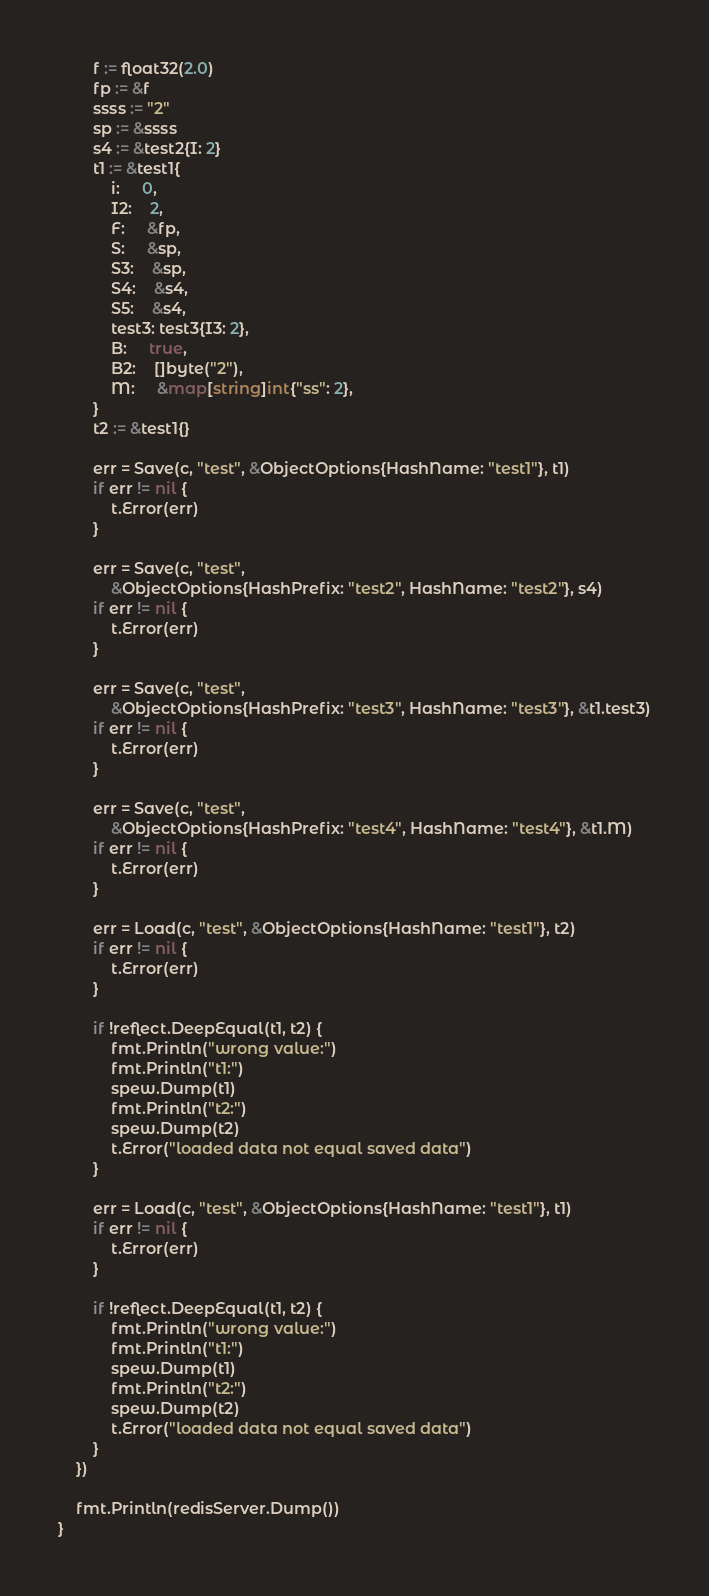<code> <loc_0><loc_0><loc_500><loc_500><_Go_>		f := float32(2.0)
		fp := &f
		ssss := "2"
		sp := &ssss
		s4 := &test2{I: 2}
		t1 := &test1{
			i:     0,
			I2:    2,
			F:     &fp,
			S:     &sp,
			S3:    &sp,
			S4:    &s4,
			S5:    &s4,
			test3: test3{I3: 2},
			B:     true,
			B2:    []byte("2"),
			M:     &map[string]int{"ss": 2},
		}
		t2 := &test1{}

		err = Save(c, "test", &ObjectOptions{HashName: "test1"}, t1)
		if err != nil {
			t.Error(err)
		}

		err = Save(c, "test",
			&ObjectOptions{HashPrefix: "test2", HashName: "test2"}, s4)
		if err != nil {
			t.Error(err)
		}

		err = Save(c, "test",
			&ObjectOptions{HashPrefix: "test3", HashName: "test3"}, &t1.test3)
		if err != nil {
			t.Error(err)
		}

		err = Save(c, "test",
			&ObjectOptions{HashPrefix: "test4", HashName: "test4"}, &t1.M)
		if err != nil {
			t.Error(err)
		}

		err = Load(c, "test", &ObjectOptions{HashName: "test1"}, t2)
		if err != nil {
			t.Error(err)
		}

		if !reflect.DeepEqual(t1, t2) {
			fmt.Println("wrong value:")
			fmt.Println("t1:")
			spew.Dump(t1)
			fmt.Println("t2:")
			spew.Dump(t2)
			t.Error("loaded data not equal saved data")
		}

		err = Load(c, "test", &ObjectOptions{HashName: "test1"}, t1)
		if err != nil {
			t.Error(err)
		}

		if !reflect.DeepEqual(t1, t2) {
			fmt.Println("wrong value:")
			fmt.Println("t1:")
			spew.Dump(t1)
			fmt.Println("t2:")
			spew.Dump(t2)
			t.Error("loaded data not equal saved data")
		}
	})

	fmt.Println(redisServer.Dump())
}
</code> 